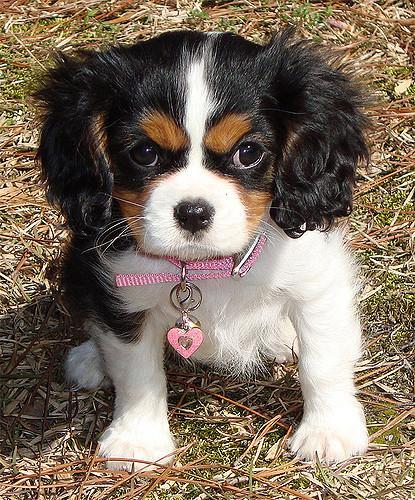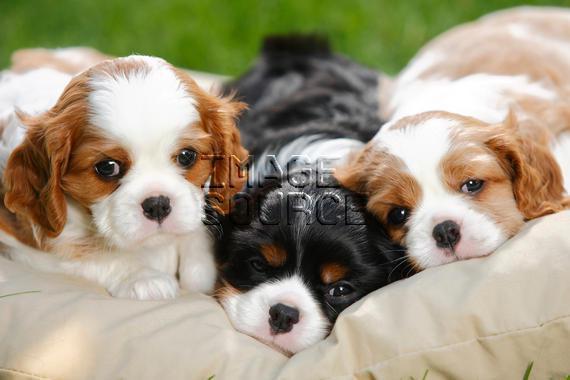The first image is the image on the left, the second image is the image on the right. For the images shown, is this caption "There are at least two puppies in the right image." true? Answer yes or no. Yes. The first image is the image on the left, the second image is the image on the right. Analyze the images presented: Is the assertion "Left image contains a puppy wearing a pink heart charm on its collar." valid? Answer yes or no. Yes. 